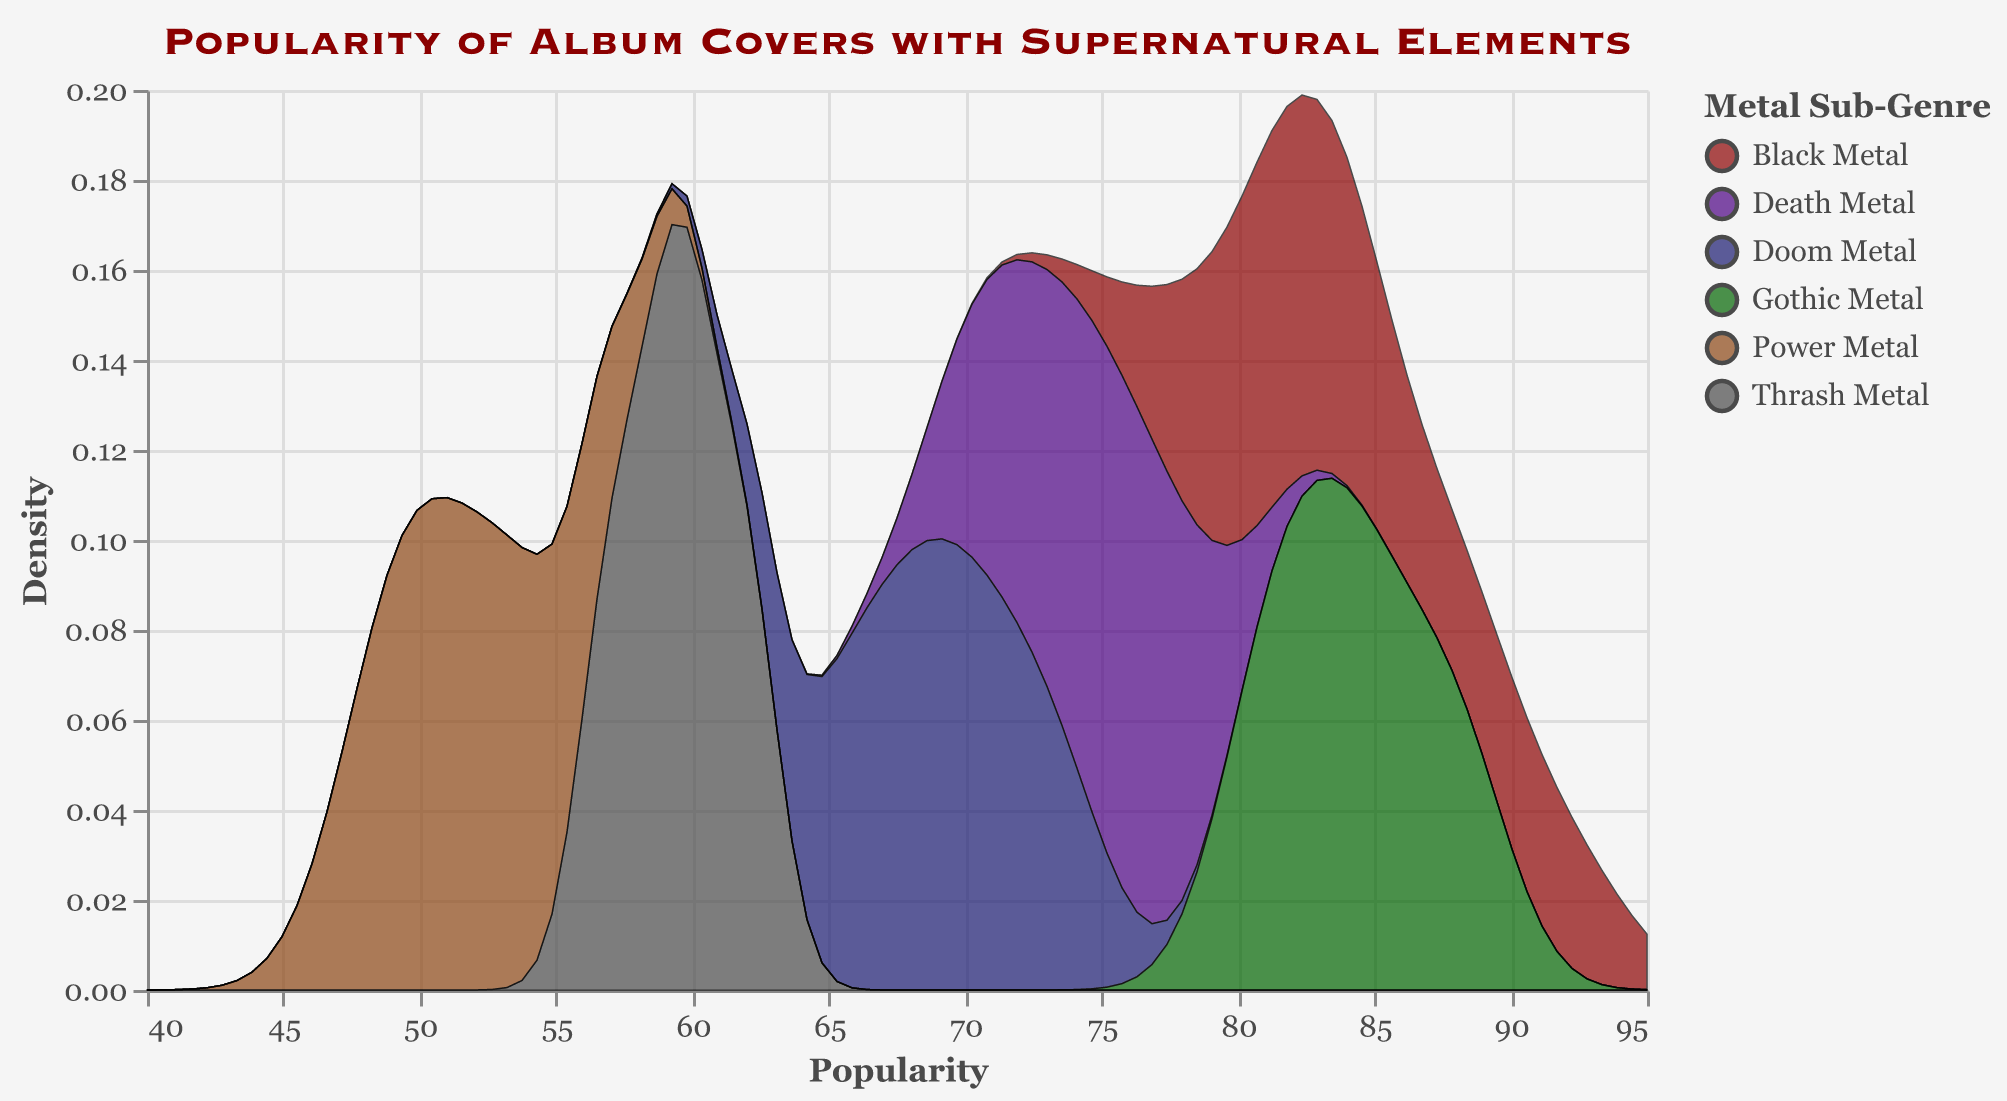What is the title of the figure? The figure's title is located at the top and usually describes the focus of the visual.
Answer: "Popularity of Album Covers with Supernatural Elements" What are the color ranges used for different sub-genres in the plot? The colors are shown in the legend and are associated with each metal sub-genre.
Answer: The colors are dark red, indigo, navy, dark green, saddle brown, and gray Which sub-genre has the highest density peak for popularity? By looking at the peaks of the density curves, you can see which sub-genre has the highest peak.
Answer: Gothic Metal Which sub-genre's popularity density is lowest around 60? We observe the density plot at the x-axis value of 60 and notice which sub-genre has the lowest curve.
Answer: Power Metal What is the range of the x-axis (Popularity)? The x-axis is labeled "Popularity" and spans a specific range of values from the figure.
Answer: 40 to 95 How do the popularity values of Thrash Metal and Doom Metal compare? This requires comparing the density curves' peaks and general shapes of these two sub-genres.
Answer: Thrash Metal has a lower peak density and is also lower in popularity range compared to Doom Metal What is the general trend of Black Metal's popularity? We analyze the density plot for Black Metal to observe its general pattern.
Answer: Black Metal shows a high density peak in the upper popularity range (around 80-90) Which sub-genre appears to have the most concentrated popularity scores? By observing the spread and peak density of the curves, we determine which is the narrowest and highest in the popularity scores.
Answer: Gothic Metal What is the median popularity value of Power Metal? Observe the density curve and determine the central value where the density plot is balanced.
Answer: Around 51-52 What can be inferred about Death Metal’s popularity spread? Analyze the width and density peak of the plot for Death Metal to describe its spread.
Answer: Death Metal's popularity is moderately spread around mid-70 values 